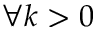Convert formula to latex. <formula><loc_0><loc_0><loc_500><loc_500>\forall k > 0</formula> 